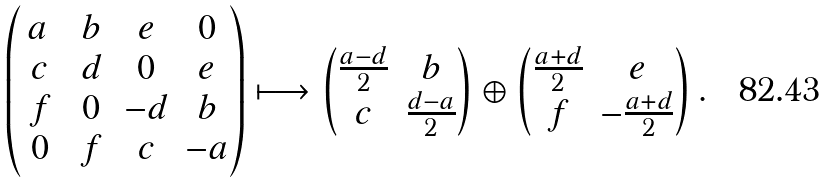<formula> <loc_0><loc_0><loc_500><loc_500>\begin{pmatrix} \, a \ & \, b \, & e & 0 \\ c & d & 0 & e \\ f & 0 & - d & b \\ 0 & f & c & - a \end{pmatrix} \longmapsto \begin{pmatrix} \frac { a - d } { 2 } & b \\ c & \frac { d - a } { 2 } \end{pmatrix} \oplus \begin{pmatrix} \frac { a + d } { 2 } & e \\ f & - \frac { a + d } { 2 } \end{pmatrix} .</formula> 